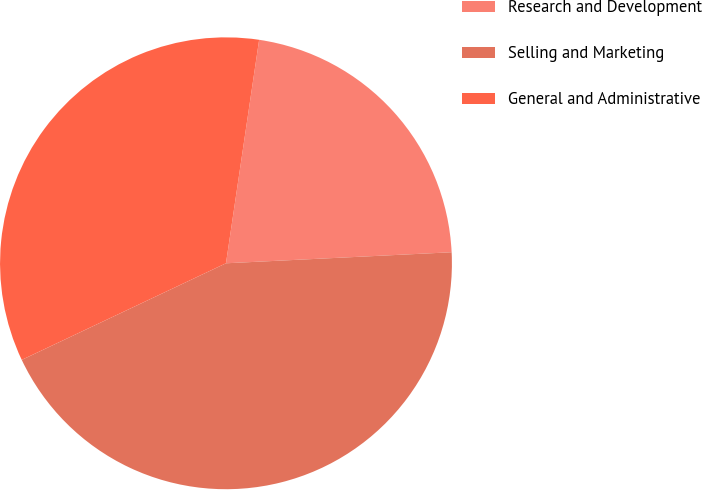Convert chart to OTSL. <chart><loc_0><loc_0><loc_500><loc_500><pie_chart><fcel>Research and Development<fcel>Selling and Marketing<fcel>General and Administrative<nl><fcel>21.88%<fcel>43.75%<fcel>34.38%<nl></chart> 